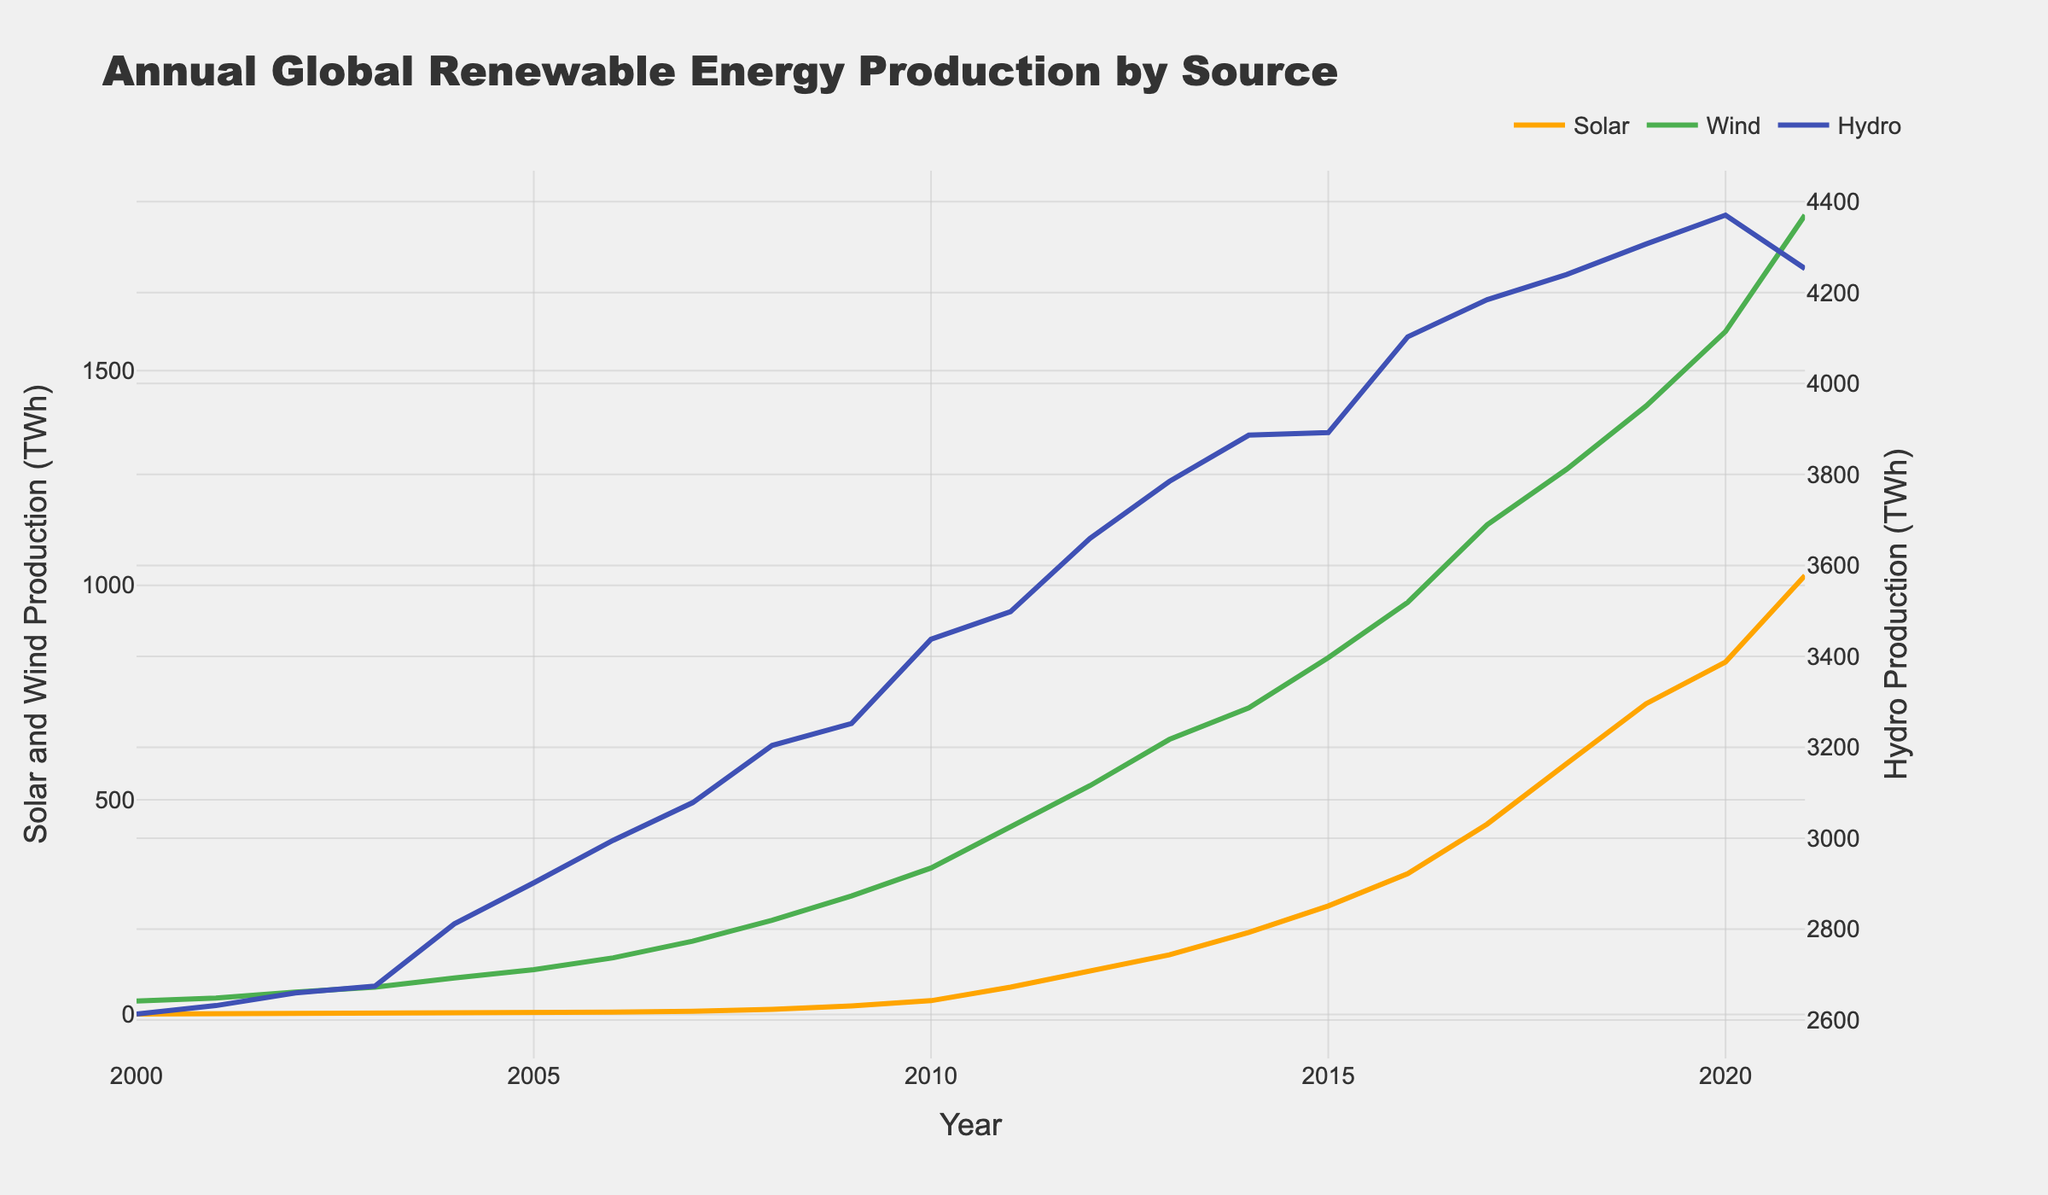What is the general trend of solar energy production from 2000 to 2021? Solar energy production has shown a continuous and steep increase over time. Starting at 1.1 TWh in 2000, it rises sharply particularly after 2010, reaching over 1000 TWh in 2021.
Answer: Continuous increase How does hydro energy production in 2021 compare to that in 2000? To compare, look at the values of hydro production for 2021 (4252.9 TWh) and 2000 (2613.2 TWh). The production has increased, although less steeply compared to other energy sources.
Answer: Increased What was the difference in wind energy production between 2010 and 2011? Refer to the values for wind energy in 2010 and 2011: 341.3 TWh and 435.6 TWh, respectively. The difference is 435.6 - 341.3 = 94.3 TWh.
Answer: 94.3 TWh What color represents wind energy production in the chart? Observing the visual attributes, wind energy production is represented by the green line.
Answer: Green Which year shows the highest production of hydro energy? By examining the peak value for hydro energy, 2020 has the highest production at 4370.5 TWh.
Answer: 2020 Compare the change in solar energy production between the years 2019 and 2020 with that between 2020 and 2021. From 2019 to 2020, solar energy production increased from 724.1 TWh to 821.3 TWh, a rise of 97.2 TWh. From 2020 to 2021, it increased from 821.3 TWh to 1022.7 TWh, an increase of 201.4 TWh. The increase is much larger from 2020 to 2021.
Answer: Larger increase from 2020 to 2021 What visual attribute distinguishes hydro energy production from solar and wind energy productions in the chart? The chart uses a secondary y-axis for hydro energy production, which is displayed in blue, separate from the primary y-axis used for solar and wind.
Answer: Secondary y-axis On average, how much did wind energy production increase per year from 2000 to 2021? First, subtract the production values of wind in 2021 from 2000: 1862.4 - 31.4 = 1831. Then, divide this by the number of years (2021 - 2000 = 21 years). The average annual increase is 1831 / 21 ≈ 87.2 TWh/year.
Answer: 87.2 TWh/year Is there any year where hydro energy production decreased compared to the previous year? Reviewing the hydro production values, we see a slight decrease from 4370.5 TWh in 2020 to 4252.9 TWh in 2021.
Answer: Yes, from 2020 to 2021 